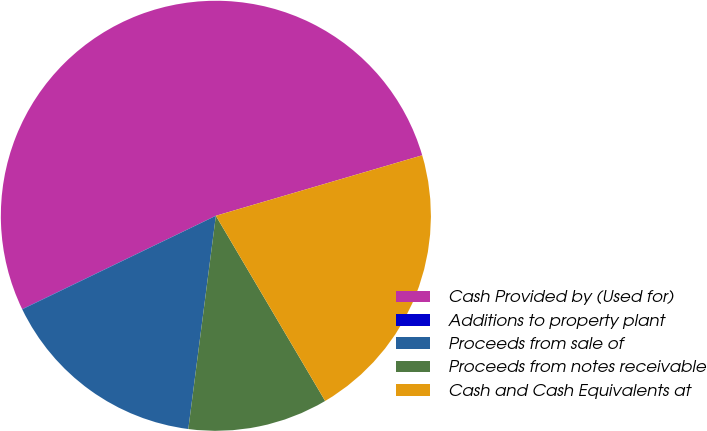Convert chart. <chart><loc_0><loc_0><loc_500><loc_500><pie_chart><fcel>Cash Provided by (Used for)<fcel>Additions to property plant<fcel>Proceeds from sale of<fcel>Proceeds from notes receivable<fcel>Cash and Cash Equivalents at<nl><fcel>52.6%<fcel>0.02%<fcel>15.79%<fcel>10.53%<fcel>21.05%<nl></chart> 